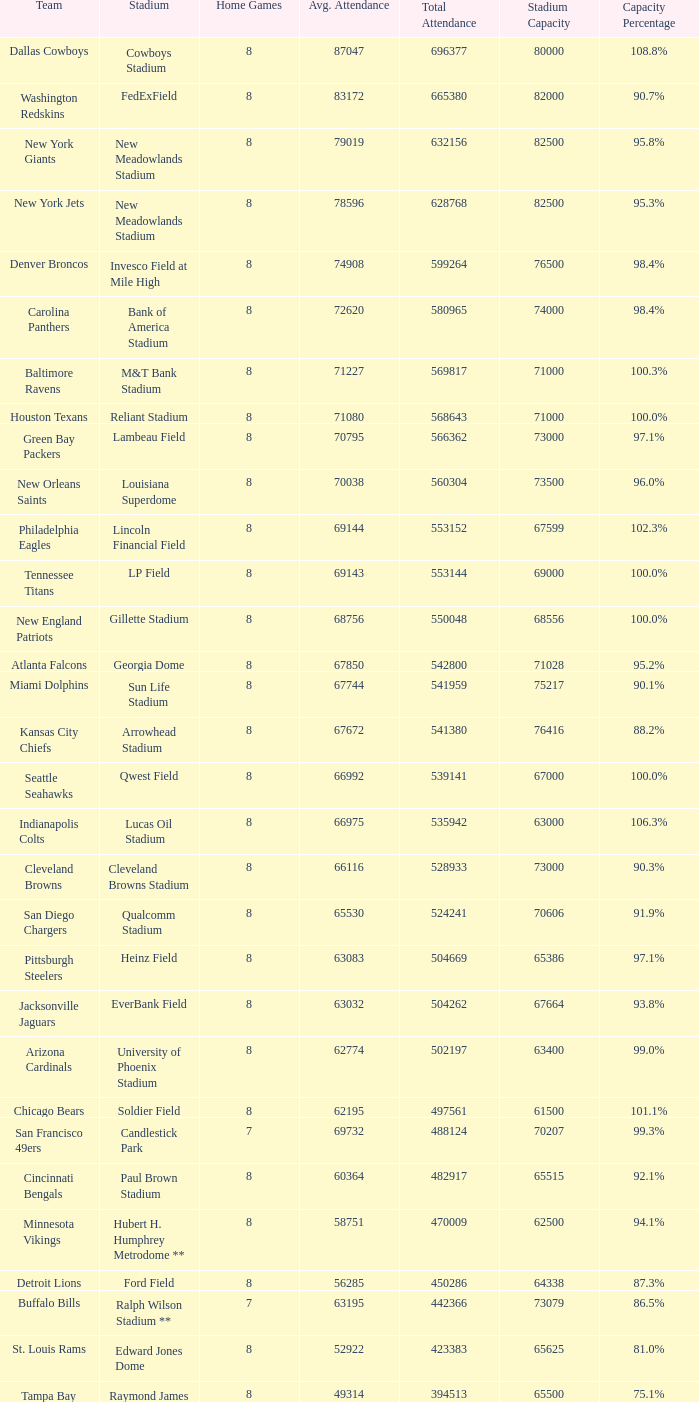What was the capacity percentage when attendance was 71080? 100.0%. 